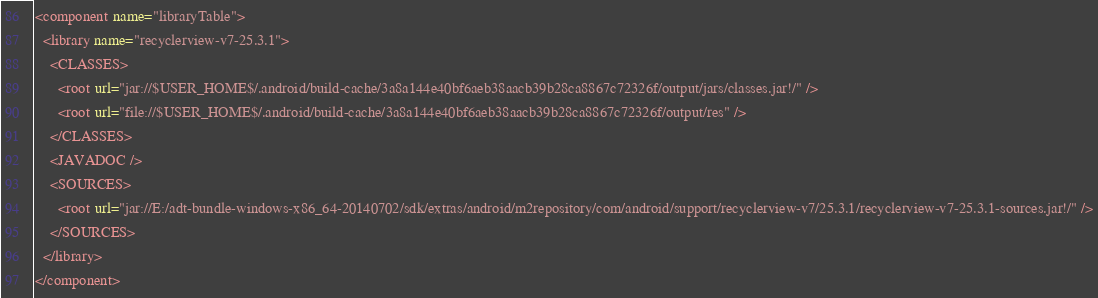Convert code to text. <code><loc_0><loc_0><loc_500><loc_500><_XML_><component name="libraryTable">
  <library name="recyclerview-v7-25.3.1">
    <CLASSES>
      <root url="jar://$USER_HOME$/.android/build-cache/3a8a144e40bf6aeb38aacb39b28ca8867c72326f/output/jars/classes.jar!/" />
      <root url="file://$USER_HOME$/.android/build-cache/3a8a144e40bf6aeb38aacb39b28ca8867c72326f/output/res" />
    </CLASSES>
    <JAVADOC />
    <SOURCES>
      <root url="jar://E:/adt-bundle-windows-x86_64-20140702/sdk/extras/android/m2repository/com/android/support/recyclerview-v7/25.3.1/recyclerview-v7-25.3.1-sources.jar!/" />
    </SOURCES>
  </library>
</component></code> 